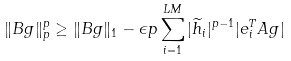Convert formula to latex. <formula><loc_0><loc_0><loc_500><loc_500>\| { B g } \| _ { p } ^ { p } \geq \| { B g } \| _ { 1 } - \epsilon p \sum _ { i = 1 } ^ { L M } | \widetilde { h } _ { i } | ^ { p - 1 } | { e } _ { i } ^ { T } { A g } |</formula> 